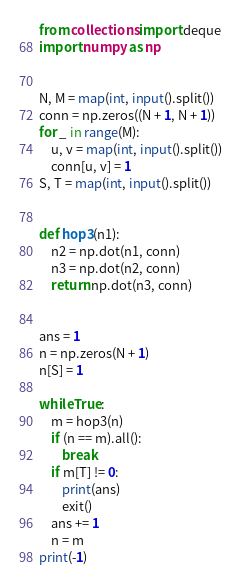<code> <loc_0><loc_0><loc_500><loc_500><_Python_>from collections import deque
import numpy as np


N, M = map(int, input().split())
conn = np.zeros((N + 1, N + 1))
for _ in range(M):
    u, v = map(int, input().split())
    conn[u, v] = 1
S, T = map(int, input().split())


def hop3(n1):
    n2 = np.dot(n1, conn)
    n3 = np.dot(n2, conn)
    return np.dot(n3, conn)


ans = 1
n = np.zeros(N + 1)
n[S] = 1

while True:
    m = hop3(n)
    if (n == m).all():
        break
    if m[T] != 0:
        print(ans)
        exit()
    ans += 1
    n = m
print(-1)
</code> 